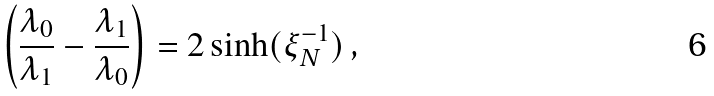Convert formula to latex. <formula><loc_0><loc_0><loc_500><loc_500>\left ( \frac { \lambda _ { 0 } } { \lambda _ { 1 } } - \frac { \lambda _ { 1 } } { \lambda _ { 0 } } \right ) = 2 \sinh ( \xi _ { N } ^ { - 1 } ) \, ,</formula> 